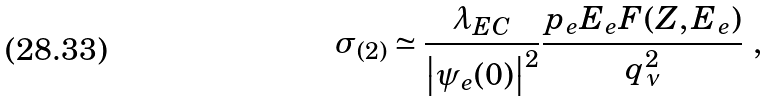<formula> <loc_0><loc_0><loc_500><loc_500>\sigma _ { ( 2 ) } \simeq \frac { \lambda _ { E C } } { \left | \psi _ { e } ( 0 ) \right | ^ { 2 } } \frac { p _ { e } E _ { e } F ( Z , E _ { e } ) } { q _ { \nu } ^ { 2 } } \ ,</formula> 